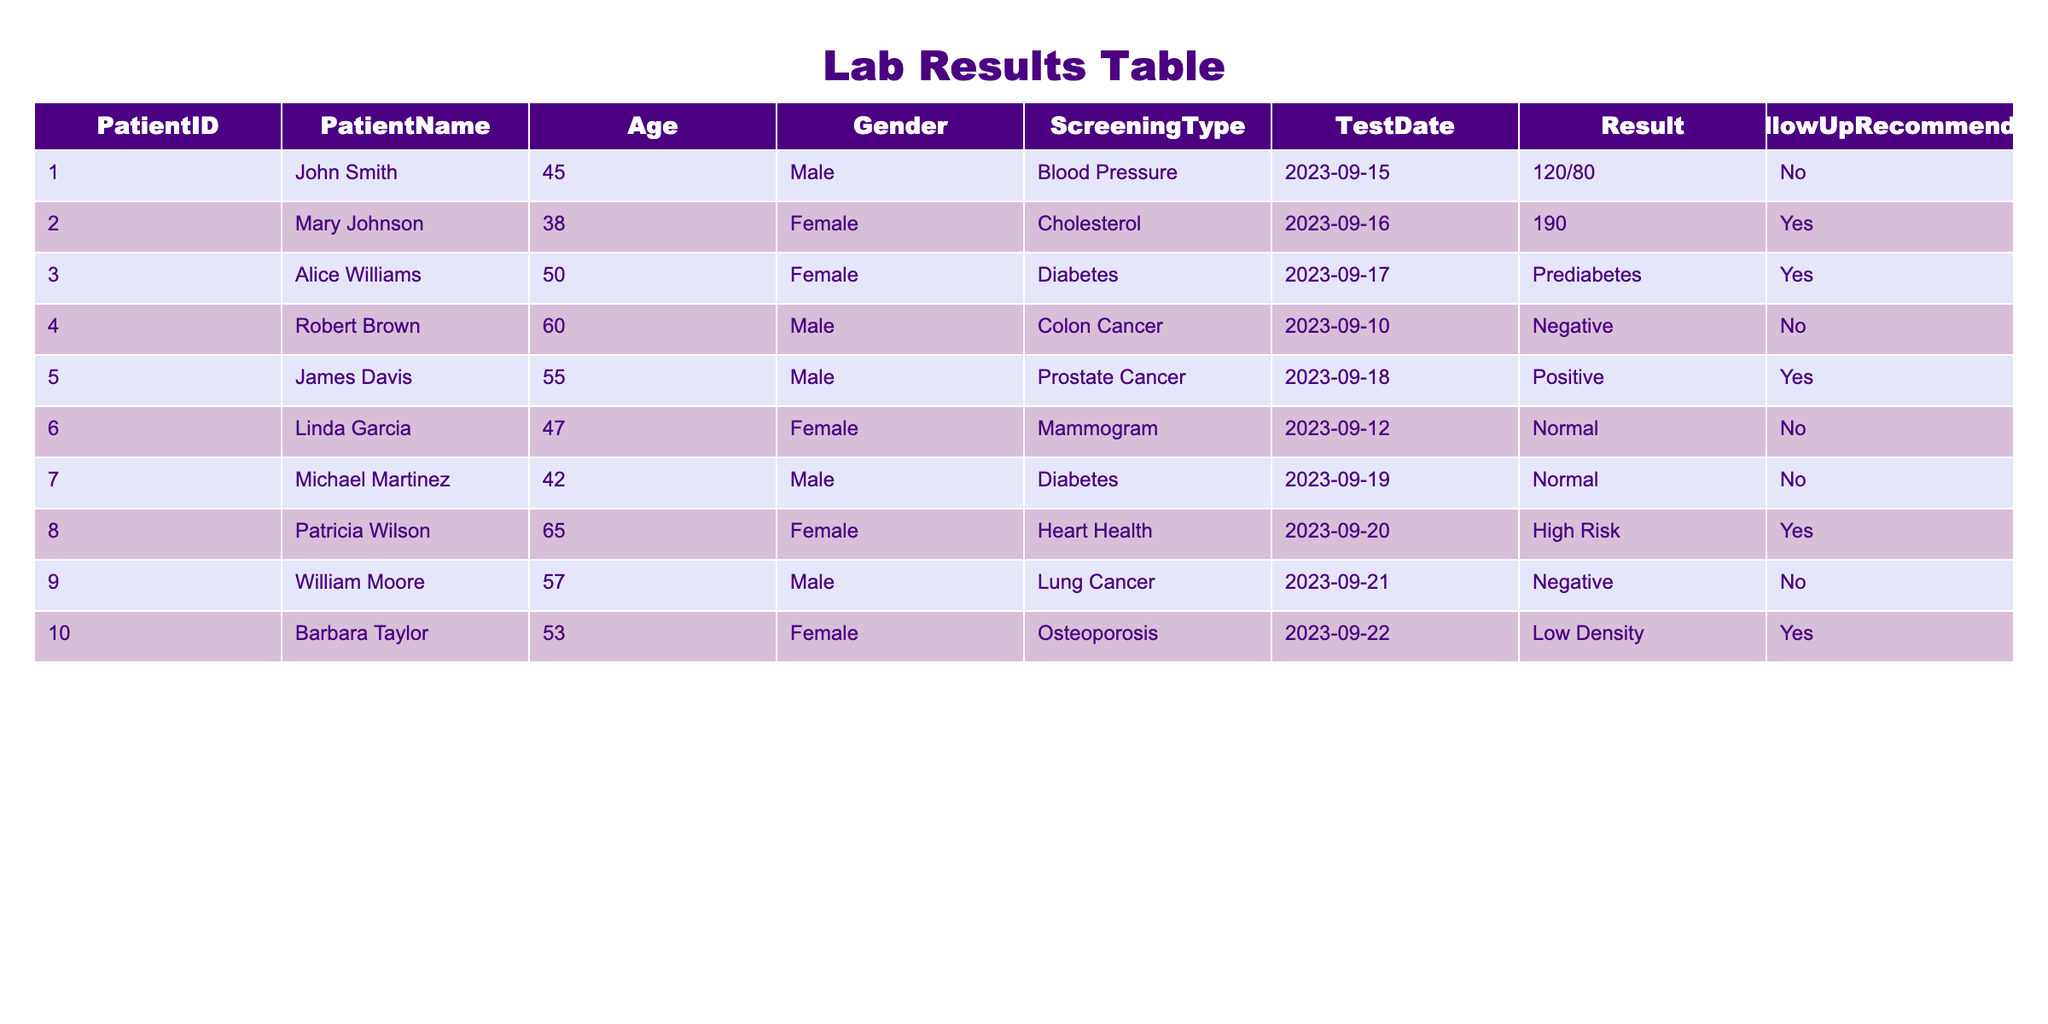What are the ages of patients who were recommended for follow-up? From the table, we look at the rows where "FollowUpRecommended" is marked as "Yes," which includes patients with Patient IDs 002, 003, 005, 008, and 010. Their ages are 38, 50, 55, 65, and 53 respectively. Thus, the ages are 38, 50, 55, 65, and 53.
Answer: 38, 50, 55, 65, 53 How many patients were screened for Diabetes? Upon reviewing the table, we find the ScreeningType "Diabetes" is listed for Patient IDs 003 and 007. Therefore, there are a total of 2 patients screened for Diabetes.
Answer: 2 Is there any patient who received a negative result for Lung Cancer? In the table, Patient ID 009 is the only entry for Lung Cancer, and the result is listed as "Negative." Therefore, the answer is yes.
Answer: Yes What is the average age of patients who were found to be at High Risk for Heart Health? The only patient found to have "High Risk" for Heart Health is Patient ID 008, who is 65 years old. Since there is only one patient, the average age is simply 65.
Answer: 65 Which patients received a recommendation for follow-up and had a positive test result? We review the table for patients with a "Yes" in the FollowUpRecommended column. Patient ID 005, who tested positive for Prostate Cancer, is the only one. Hence, the patient is James Davis (Age 55).
Answer: James Davis How many patients had a normal result for their Screening? Inspecting the Results column, we find that Linda Garcia and Michael Martinez both had "Normal" results for Mammogram and Diabetes, respectively. Therefore, the total is 2 patients with normal results.
Answer: 2 Is there any female patient aged 50 or older who was not recommended for follow-up? Looking through the data, we see that Alice Williams (age 50, Diabetes) and Linda Garcia (age 47) were recommended for follow-up; however, Robert Brown's (age 60) colon cancer result was negative with no follow-up recommended. Therefore, the answer is yes.
Answer: Yes What proportion of the recommended follow-up cases resulted in a positive test result? There are 5 patients who were recommended for follow-up (IDs: 002, 003, 005, 008, 010). Out of these, only Patient ID 005 tested positive for Prostate Cancer, which gives us a proportion of 1 out of 5: 1/5 = 0.2 or 20%.
Answer: 20% 